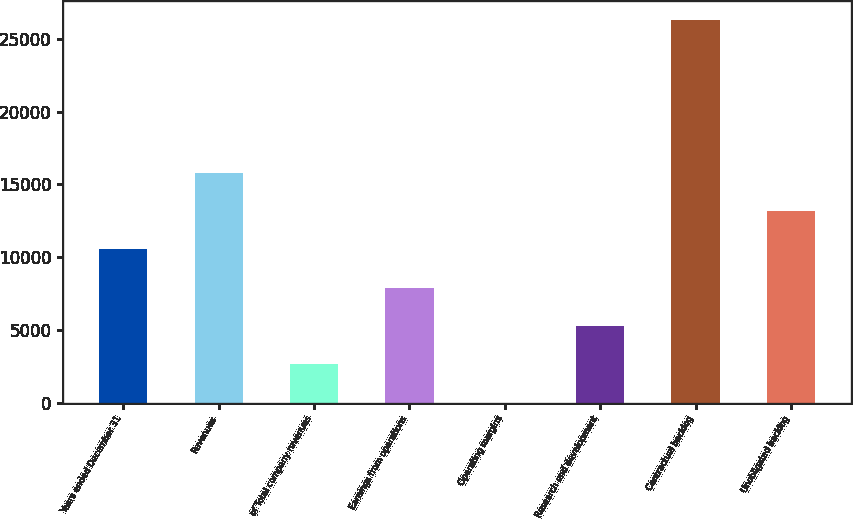Convert chart. <chart><loc_0><loc_0><loc_500><loc_500><bar_chart><fcel>Years ended December 31<fcel>Revenues<fcel>of Total company revenues<fcel>Earnings from operations<fcel>Operating margins<fcel>Research and development<fcel>Contractual backlog<fcel>Unobligated backlog<nl><fcel>10530.9<fcel>15790.9<fcel>2640.82<fcel>7900.86<fcel>10.8<fcel>5270.84<fcel>26311<fcel>13160.9<nl></chart> 